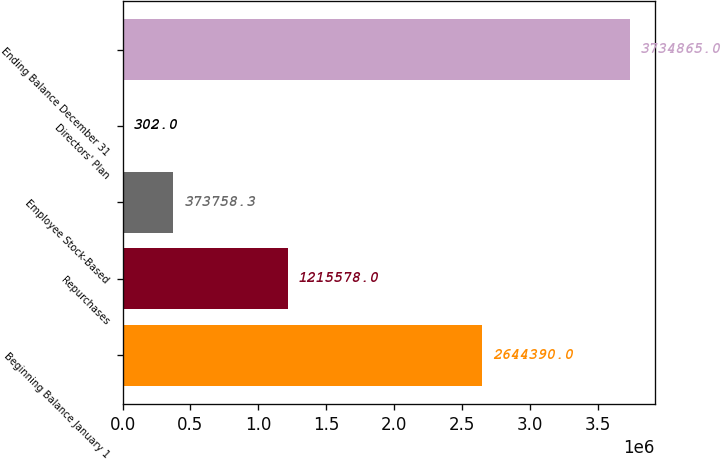Convert chart. <chart><loc_0><loc_0><loc_500><loc_500><bar_chart><fcel>Beginning Balance January 1<fcel>Repurchases<fcel>Employee Stock-Based<fcel>Directors' Plan<fcel>Ending Balance December 31<nl><fcel>2.64439e+06<fcel>1.21558e+06<fcel>373758<fcel>302<fcel>3.73486e+06<nl></chart> 